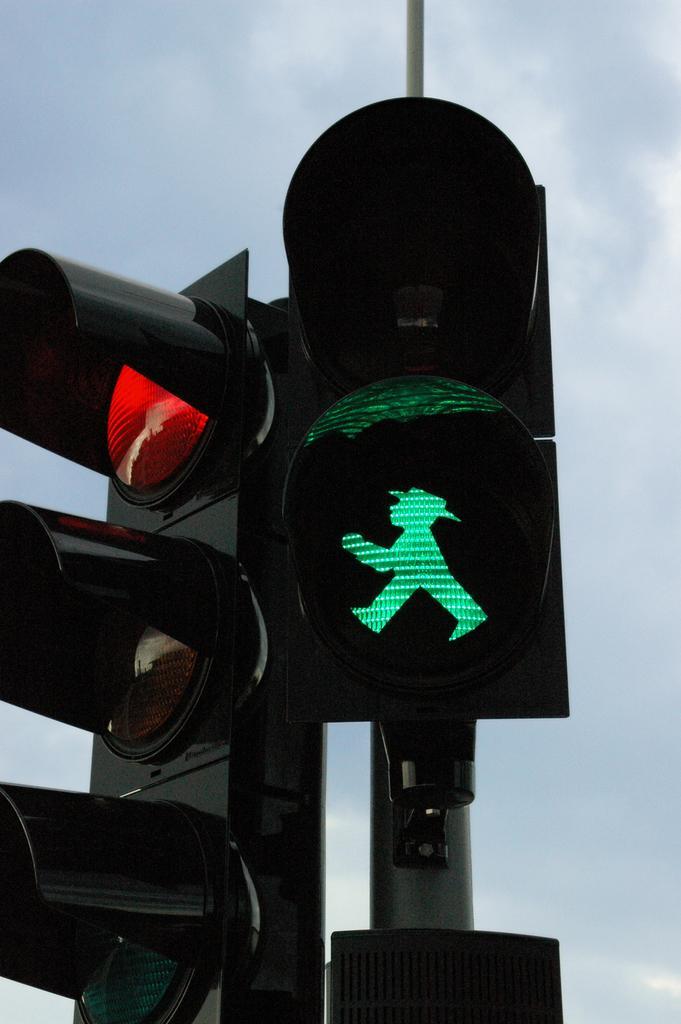In one or two sentences, can you explain what this image depicts? In this picture we can observe traffic signals fixed to the poles. In the background there is a sky. 